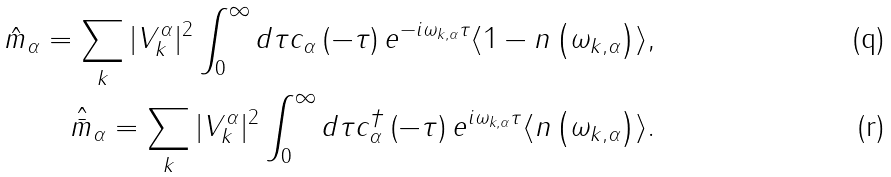<formula> <loc_0><loc_0><loc_500><loc_500>\hat { m } _ { \alpha } = \sum _ { k } | V ^ { \alpha } _ { k } | ^ { 2 } \int _ { 0 } ^ { \infty } d \tau c _ { \alpha } \left ( - \tau \right ) e ^ { - i \omega _ { k , \alpha } \tau } \langle 1 - n \left ( \omega _ { k , \alpha } \right ) \rangle , \\ \hat { \bar { m } } _ { \alpha } = \sum _ { k } | V ^ { \alpha } _ { k } | ^ { 2 } \int _ { 0 } ^ { \infty } d \tau c ^ { \dag } _ { \alpha } \left ( - \tau \right ) e ^ { i \omega _ { k , \alpha } \tau } \langle n \left ( \omega _ { k , \alpha } \right ) \rangle .</formula> 